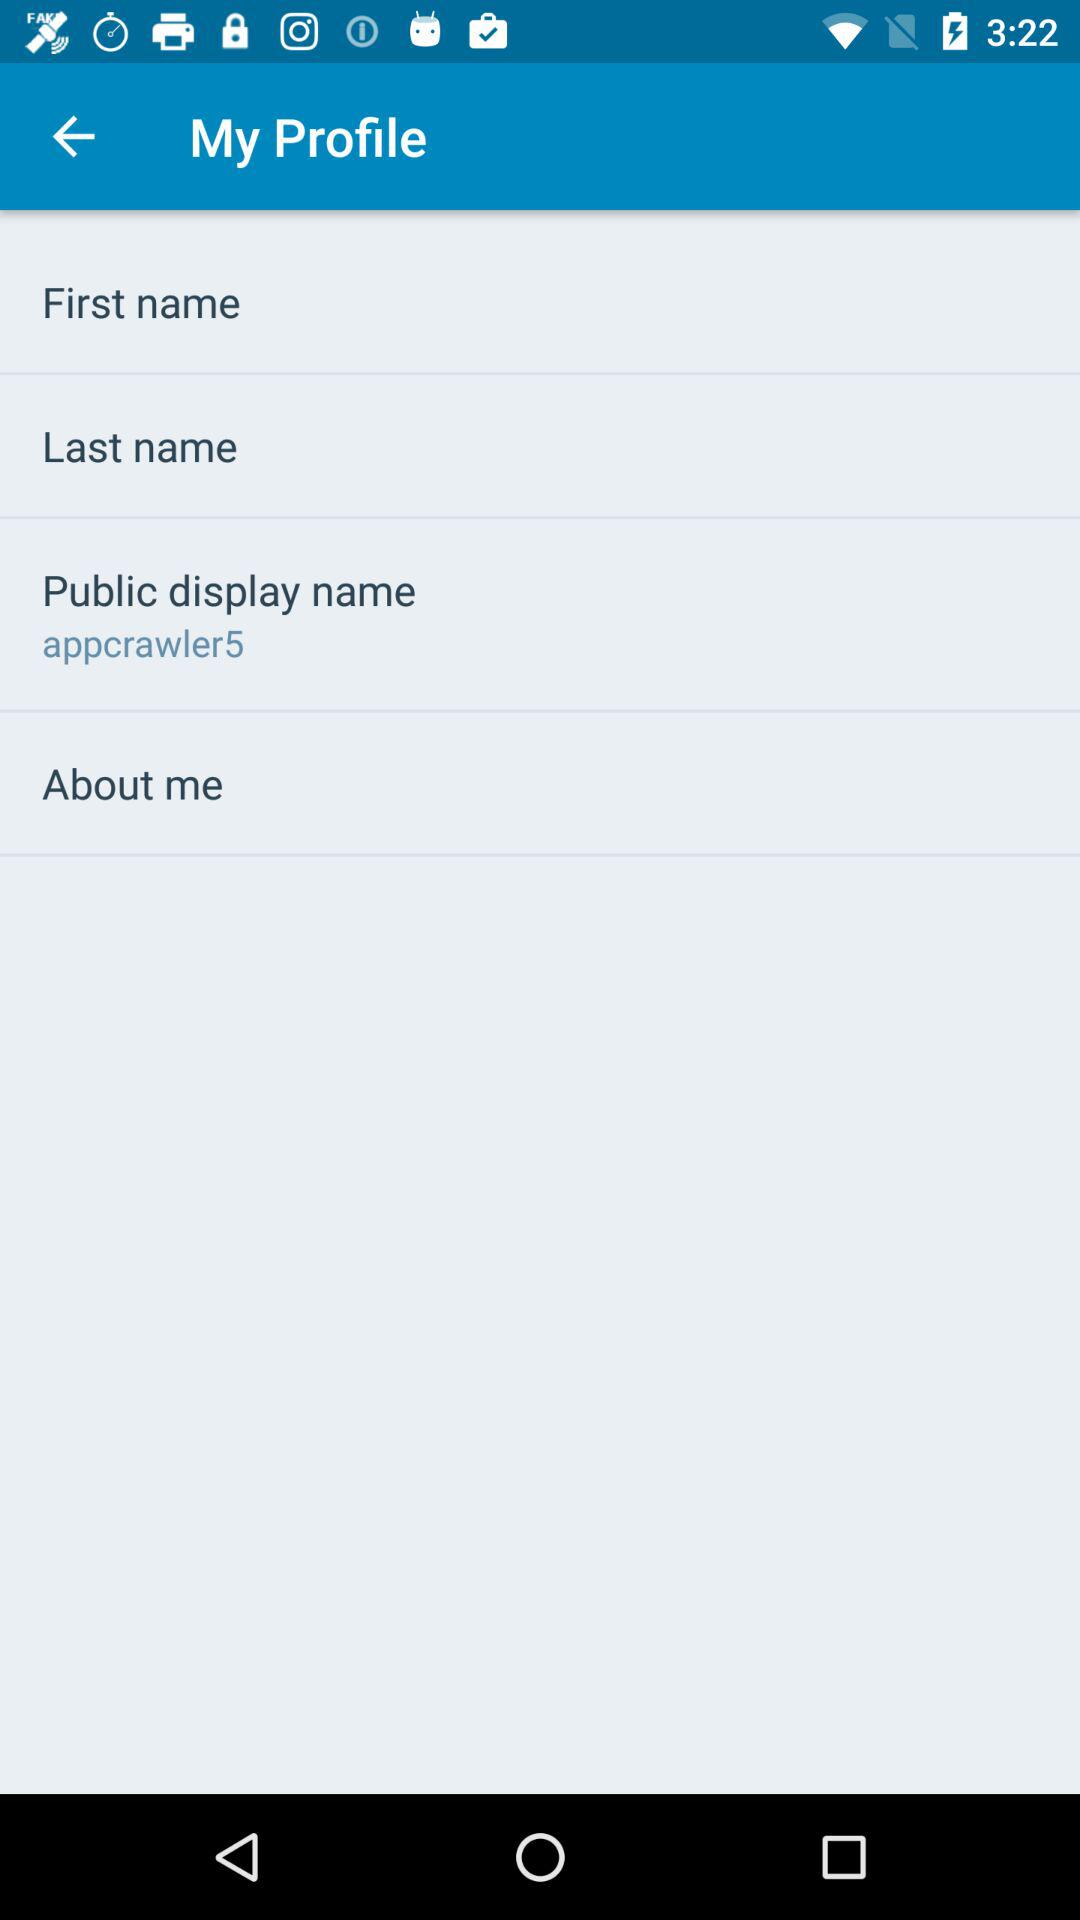To whom does this profile belong?
When the provided information is insufficient, respond with <no answer>. <no answer> 